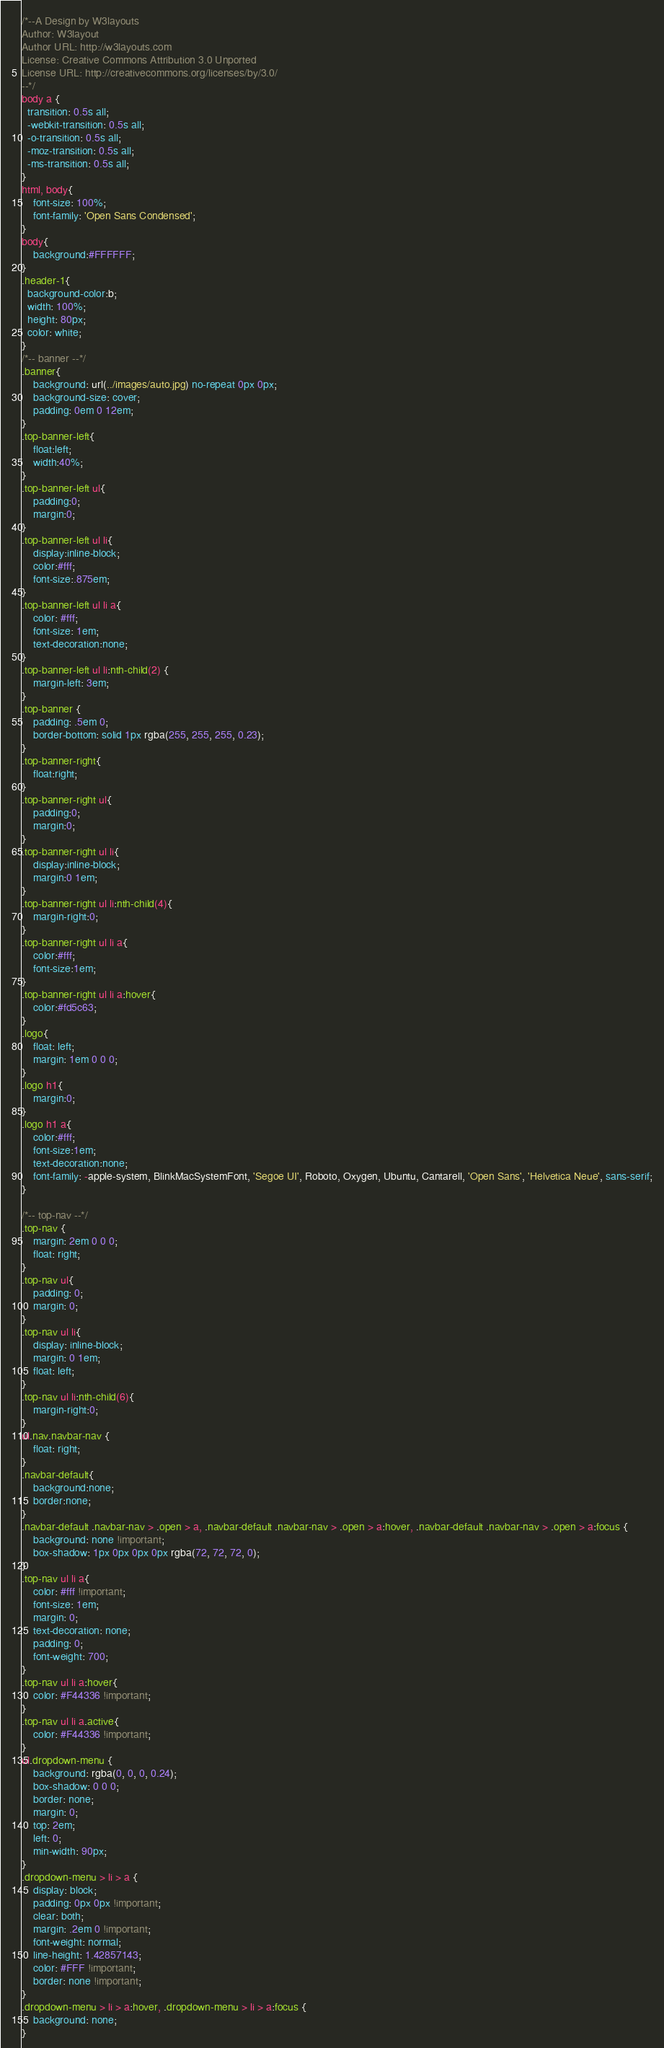<code> <loc_0><loc_0><loc_500><loc_500><_CSS_>/*--A Design by W3layouts 
Author: W3layout
Author URL: http://w3layouts.com
License: Creative Commons Attribution 3.0 Unported
License URL: http://creativecommons.org/licenses/by/3.0/
--*/
body a {
  transition: 0.5s all;
  -webkit-transition: 0.5s all;
  -o-transition: 0.5s all;
  -moz-transition: 0.5s all;
  -ms-transition: 0.5s all;
}
html, body{
    font-size: 100%;
	font-family: 'Open Sans Condensed';
}
body{
	background:#FFFFFF;
}
.header-1{
  background-color:b;
  width: 100%;
  height: 80px;
  color: white;
}
/*-- banner --*/
.banner{
    background: url(../images/auto.jpg) no-repeat 0px 0px;
    background-size: cover;
    padding: 0em 0 12em;
}
.top-banner-left{
	float:left;
	width:40%;
}
.top-banner-left ul{
	padding:0;
	margin:0;
}
.top-banner-left ul li{
	display:inline-block;
	color:#fff;
	font-size:.875em;
}
.top-banner-left ul li a{
    color: #fff;
    font-size: 1em;
	text-decoration:none;
}
.top-banner-left ul li:nth-child(2) {
    margin-left: 3em;
}
.top-banner {
    padding: .5em 0;
    border-bottom: solid 1px rgba(255, 255, 255, 0.23);
}
.top-banner-right{
	float:right;
}
.top-banner-right ul{
	padding:0;
	margin:0;
}
.top-banner-right ul li{
	display:inline-block;
	margin:0 1em;
}
.top-banner-right ul li:nth-child(4){
	margin-right:0;
}
.top-banner-right ul li a{
	color:#fff;
	font-size:1em;
}
.top-banner-right ul li a:hover{
	color:#fd5c63;
}
.logo{
    float: left;
    margin: 1em 0 0 0;
}
.logo h1{
	margin:0;
}
.logo h1 a{
	color:#fff;
	font-size:1em;
	text-decoration:none;
	font-family: -apple-system, BlinkMacSystemFont, 'Segoe UI', Roboto, Oxygen, Ubuntu, Cantarell, 'Open Sans', 'Helvetica Neue', sans-serif;
}
 
/*-- top-nav --*/
.top-nav {
    margin: 2em 0 0 0;
	float: right;
}
.top-nav ul{
    padding: 0;
    margin: 0;
}
.top-nav ul li{
    display: inline-block;
    margin: 0 1em;
    float: left;
}
.top-nav ul li:nth-child(6){
	margin-right:0;
}
ul.nav.navbar-nav {
    float: right;
}
.navbar-default{
	background:none;
	border:none;
}
.navbar-default .navbar-nav > .open > a, .navbar-default .navbar-nav > .open > a:hover, .navbar-default .navbar-nav > .open > a:focus {
    background: none !important;
    box-shadow: 1px 0px 0px 0px rgba(72, 72, 72, 0);
}
.top-nav ul li a{
    color: #fff !important;
    font-size: 1em;
    margin: 0;
    text-decoration: none;
    padding: 0;
    font-weight: 700;
}
.top-nav ul li a:hover{
    color: #F44336 !important;
}
.top-nav ul li a.active{
    color: #F44336 !important;
}
ul.dropdown-menu {
    background: rgba(0, 0, 0, 0.24);
    box-shadow: 0 0 0;
    border: none;
    margin: 0;
    top: 2em;
    left: 0;
    min-width: 90px;
}
.dropdown-menu > li > a {
    display: block;
    padding: 0px 0px !important;
    clear: both;
    margin: .2em 0 !important;
    font-weight: normal;
    line-height: 1.42857143;
    color: #FFF !important;
    border: none !important;
}
.dropdown-menu > li > a:hover, .dropdown-menu > li > a:focus {
    background: none;
}</code> 